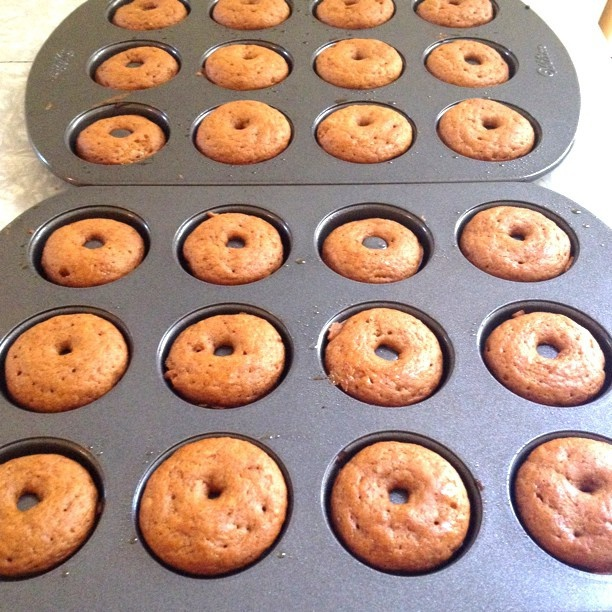Describe the objects in this image and their specific colors. I can see donut in lightyellow, orange, gray, tan, and brown tones, donut in lightyellow, orange, tan, brown, and red tones, donut in lightyellow, salmon, and tan tones, donut in lightyellow, salmon, brown, and ivory tones, and donut in lightyellow, orange, brown, and maroon tones in this image. 